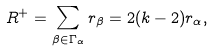Convert formula to latex. <formula><loc_0><loc_0><loc_500><loc_500>R ^ { + } = \sum _ { \beta \in \Gamma _ { \alpha } } r _ { \beta } = 2 ( k - 2 ) r _ { \alpha } ,</formula> 